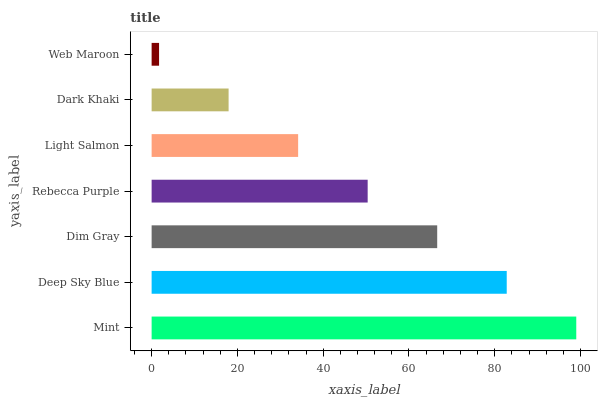Is Web Maroon the minimum?
Answer yes or no. Yes. Is Mint the maximum?
Answer yes or no. Yes. Is Deep Sky Blue the minimum?
Answer yes or no. No. Is Deep Sky Blue the maximum?
Answer yes or no. No. Is Mint greater than Deep Sky Blue?
Answer yes or no. Yes. Is Deep Sky Blue less than Mint?
Answer yes or no. Yes. Is Deep Sky Blue greater than Mint?
Answer yes or no. No. Is Mint less than Deep Sky Blue?
Answer yes or no. No. Is Rebecca Purple the high median?
Answer yes or no. Yes. Is Rebecca Purple the low median?
Answer yes or no. Yes. Is Deep Sky Blue the high median?
Answer yes or no. No. Is Dark Khaki the low median?
Answer yes or no. No. 